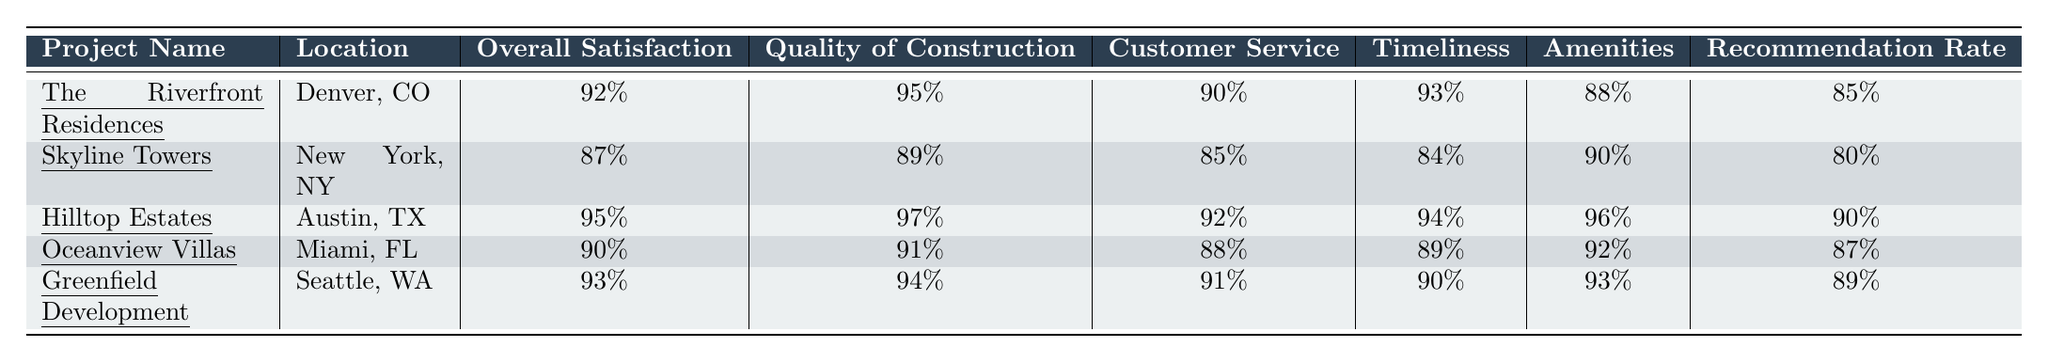What is the overall satisfaction percentage for "Hilltop Estates"? The overall satisfaction percentage for "Hilltop Estates" is provided directly in the table. It shows 95%.
Answer: 95% Which project has the highest quality of construction rating? By comparing the quality of construction ratings across all projects, "Hilltop Estates" has the highest rating at 97%.
Answer: Hilltop Estates What is the recommendation rate for "The Riverfront Residences"? The recommendation rate for "The Riverfront Residences" is clearly listed in the table as 85%.
Answer: 85% What are the average satisfaction percentages for customer service across all projects? The customer service ratings are: 90%, 85%, 92%, 88%, and 91%. To find the average, sum these values: 90 + 85 + 92 + 88 + 91 = 446. There are 5 projects (446/5 = 89.2).
Answer: 89.2% Is the overall satisfaction for "Oceanview Villas" greater than 90%? The overall satisfaction for "Oceanview Villas" is stated in the table as 90%, which is not greater than 90%.
Answer: No Which project has the lowest recommendation rate? The recommendation rates are 85%, 80%, 90%, 87%, and 89%. The lowest rate is from "Skyline Towers" at 80%.
Answer: Skyline Towers What is the difference in overall satisfaction between "Hilltop Estates" and "Oceanview Villas"? The overall satisfaction for "Hilltop Estates" is 95%, and for "Oceanview Villas" it is 90%. The difference is 95 - 90 = 5.
Answer: 5 How many projects have an overall satisfaction of 90% or higher? The projects with overall satisfaction of 90% or higher are "The Riverfront Residences," "Hilltop Estates," "Oceanview Villas," and "Greenfield Development." This totals four projects.
Answer: 4 What is the average rating for amenities across all projects? The amenities ratings are: 88%, 90%, 96%, 92%, and 93%. To find the average, sum these: 88 + 90 + 96 + 92 + 93 = 459. There are 5 projects (459/5 = 91.8).
Answer: 91.8 Is the customer service rating for "Skyline Towers" below 85%? The customer service rating for "Skyline Towers" is 85%, which is not below 85%.
Answer: No 